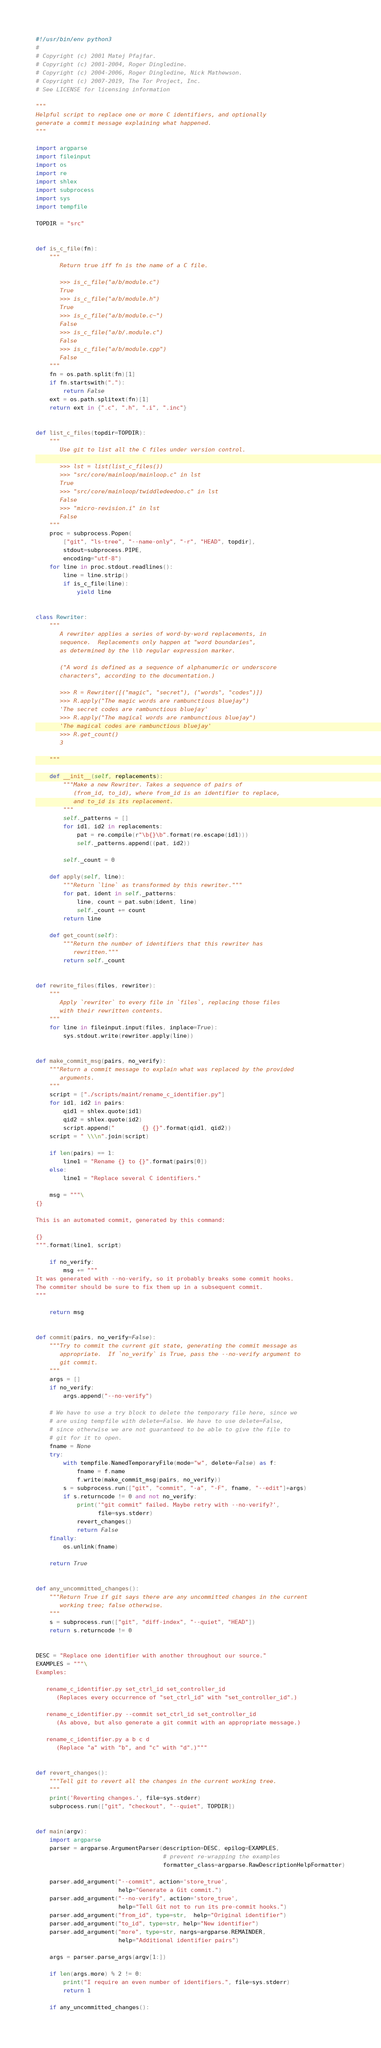<code> <loc_0><loc_0><loc_500><loc_500><_Python_>#!/usr/bin/env python3
#
# Copyright (c) 2001 Matej Pfajfar.
# Copyright (c) 2001-2004, Roger Dingledine.
# Copyright (c) 2004-2006, Roger Dingledine, Nick Mathewson.
# Copyright (c) 2007-2019, The Tor Project, Inc.
# See LICENSE for licensing information

"""
Helpful script to replace one or more C identifiers, and optionally
generate a commit message explaining what happened.
"""

import argparse
import fileinput
import os
import re
import shlex
import subprocess
import sys
import tempfile

TOPDIR = "src"


def is_c_file(fn):
    """
       Return true iff fn is the name of a C file.

       >>> is_c_file("a/b/module.c")
       True
       >>> is_c_file("a/b/module.h")
       True
       >>> is_c_file("a/b/module.c~")
       False
       >>> is_c_file("a/b/.module.c")
       False
       >>> is_c_file("a/b/module.cpp")
       False
    """
    fn = os.path.split(fn)[1]
    if fn.startswith("."):
        return False
    ext = os.path.splitext(fn)[1]
    return ext in {".c", ".h", ".i", ".inc"}


def list_c_files(topdir=TOPDIR):
    """
       Use git to list all the C files under version control.

       >>> lst = list(list_c_files())
       >>> "src/core/mainloop/mainloop.c" in lst
       True
       >>> "src/core/mainloop/twiddledeedoo.c" in lst
       False
       >>> "micro-revision.i" in lst
       False
    """
    proc = subprocess.Popen(
        ["git", "ls-tree", "--name-only", "-r", "HEAD", topdir],
        stdout=subprocess.PIPE,
        encoding="utf-8")
    for line in proc.stdout.readlines():
        line = line.strip()
        if is_c_file(line):
            yield line


class Rewriter:
    """
       A rewriter applies a series of word-by-word replacements, in
       sequence.  Replacements only happen at "word boundaries",
       as determined by the \\b regular expression marker.

       ("A word is defined as a sequence of alphanumeric or underscore
       characters", according to the documentation.)

       >>> R = Rewriter([("magic", "secret"), ("words", "codes")])
       >>> R.apply("The magic words are rambunctious bluejay")
       'The secret codes are rambunctious bluejay'
       >>> R.apply("The magical words are rambunctious bluejay")
       'The magical codes are rambunctious bluejay'
       >>> R.get_count()
       3

    """

    def __init__(self, replacements):
        """Make a new Rewriter. Takes a sequence of pairs of
           (from_id, to_id), where from_id is an identifier to replace,
           and to_id is its replacement.
        """
        self._patterns = []
        for id1, id2 in replacements:
            pat = re.compile(r"\b{}\b".format(re.escape(id1)))
            self._patterns.append((pat, id2))

        self._count = 0

    def apply(self, line):
        """Return `line` as transformed by this rewriter."""
        for pat, ident in self._patterns:
            line, count = pat.subn(ident, line)
            self._count += count
        return line

    def get_count(self):
        """Return the number of identifiers that this rewriter has
           rewritten."""
        return self._count


def rewrite_files(files, rewriter):
    """
       Apply `rewriter` to every file in `files`, replacing those files
       with their rewritten contents.
    """
    for line in fileinput.input(files, inplace=True):
        sys.stdout.write(rewriter.apply(line))


def make_commit_msg(pairs, no_verify):
    """Return a commit message to explain what was replaced by the provided
       arguments.
    """
    script = ["./scripts/maint/rename_c_identifier.py"]
    for id1, id2 in pairs:
        qid1 = shlex.quote(id1)
        qid2 = shlex.quote(id2)
        script.append("        {} {}".format(qid1, qid2))
    script = " \\\n".join(script)

    if len(pairs) == 1:
        line1 = "Rename {} to {}".format(pairs[0])
    else:
        line1 = "Replace several C identifiers."

    msg = """\
{}

This is an automated commit, generated by this command:

{}
""".format(line1, script)

    if no_verify:
        msg += """
It was generated with --no-verify, so it probably breaks some commit hooks.
The commiter should be sure to fix them up in a subsequent commit.
"""

    return msg


def commit(pairs, no_verify=False):
    """Try to commit the current git state, generating the commit message as
       appropriate.  If `no_verify` is True, pass the --no-verify argument to
       git commit.
    """
    args = []
    if no_verify:
        args.append("--no-verify")

    # We have to use a try block to delete the temporary file here, since we
    # are using tempfile with delete=False. We have to use delete=False,
    # since otherwise we are not guaranteed to be able to give the file to
    # git for it to open.
    fname = None
    try:
        with tempfile.NamedTemporaryFile(mode="w", delete=False) as f:
            fname = f.name
            f.write(make_commit_msg(pairs, no_verify))
        s = subprocess.run(["git", "commit", "-a", "-F", fname, "--edit"]+args)
        if s.returncode != 0 and not no_verify:
            print('"git commit" failed. Maybe retry with --no-verify?',
                  file=sys.stderr)
            revert_changes()
            return False
    finally:
        os.unlink(fname)

    return True


def any_uncommitted_changes():
    """Return True if git says there are any uncommitted changes in the current
       working tree; false otherwise.
    """
    s = subprocess.run(["git", "diff-index", "--quiet", "HEAD"])
    return s.returncode != 0


DESC = "Replace one identifier with another throughout our source."
EXAMPLES = """\
Examples:

   rename_c_identifier.py set_ctrl_id set_controller_id
      (Replaces every occurrence of "set_ctrl_id" with "set_controller_id".)

   rename_c_identifier.py --commit set_ctrl_id set_controller_id
      (As above, but also generate a git commit with an appropriate message.)

   rename_c_identifier.py a b c d
      (Replace "a" with "b", and "c" with "d".)"""


def revert_changes():
    """Tell git to revert all the changes in the current working tree.
    """
    print('Reverting changes.', file=sys.stderr)
    subprocess.run(["git", "checkout", "--quiet", TOPDIR])


def main(argv):
    import argparse
    parser = argparse.ArgumentParser(description=DESC, epilog=EXAMPLES,
                                     # prevent re-wrapping the examples
                                     formatter_class=argparse.RawDescriptionHelpFormatter)

    parser.add_argument("--commit", action='store_true',
                        help="Generate a Git commit.")
    parser.add_argument("--no-verify", action='store_true',
                        help="Tell Git not to run its pre-commit hooks.")
    parser.add_argument("from_id", type=str,  help="Original identifier")
    parser.add_argument("to_id", type=str, help="New identifier")
    parser.add_argument("more", type=str, nargs=argparse.REMAINDER,
                        help="Additional identifier pairs")

    args = parser.parse_args(argv[1:])

    if len(args.more) % 2 != 0:
        print("I require an even number of identifiers.", file=sys.stderr)
        return 1

    if any_uncommitted_changes():</code> 